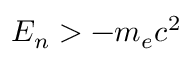Convert formula to latex. <formula><loc_0><loc_0><loc_500><loc_500>E _ { n } > - m _ { e } c ^ { 2 }</formula> 